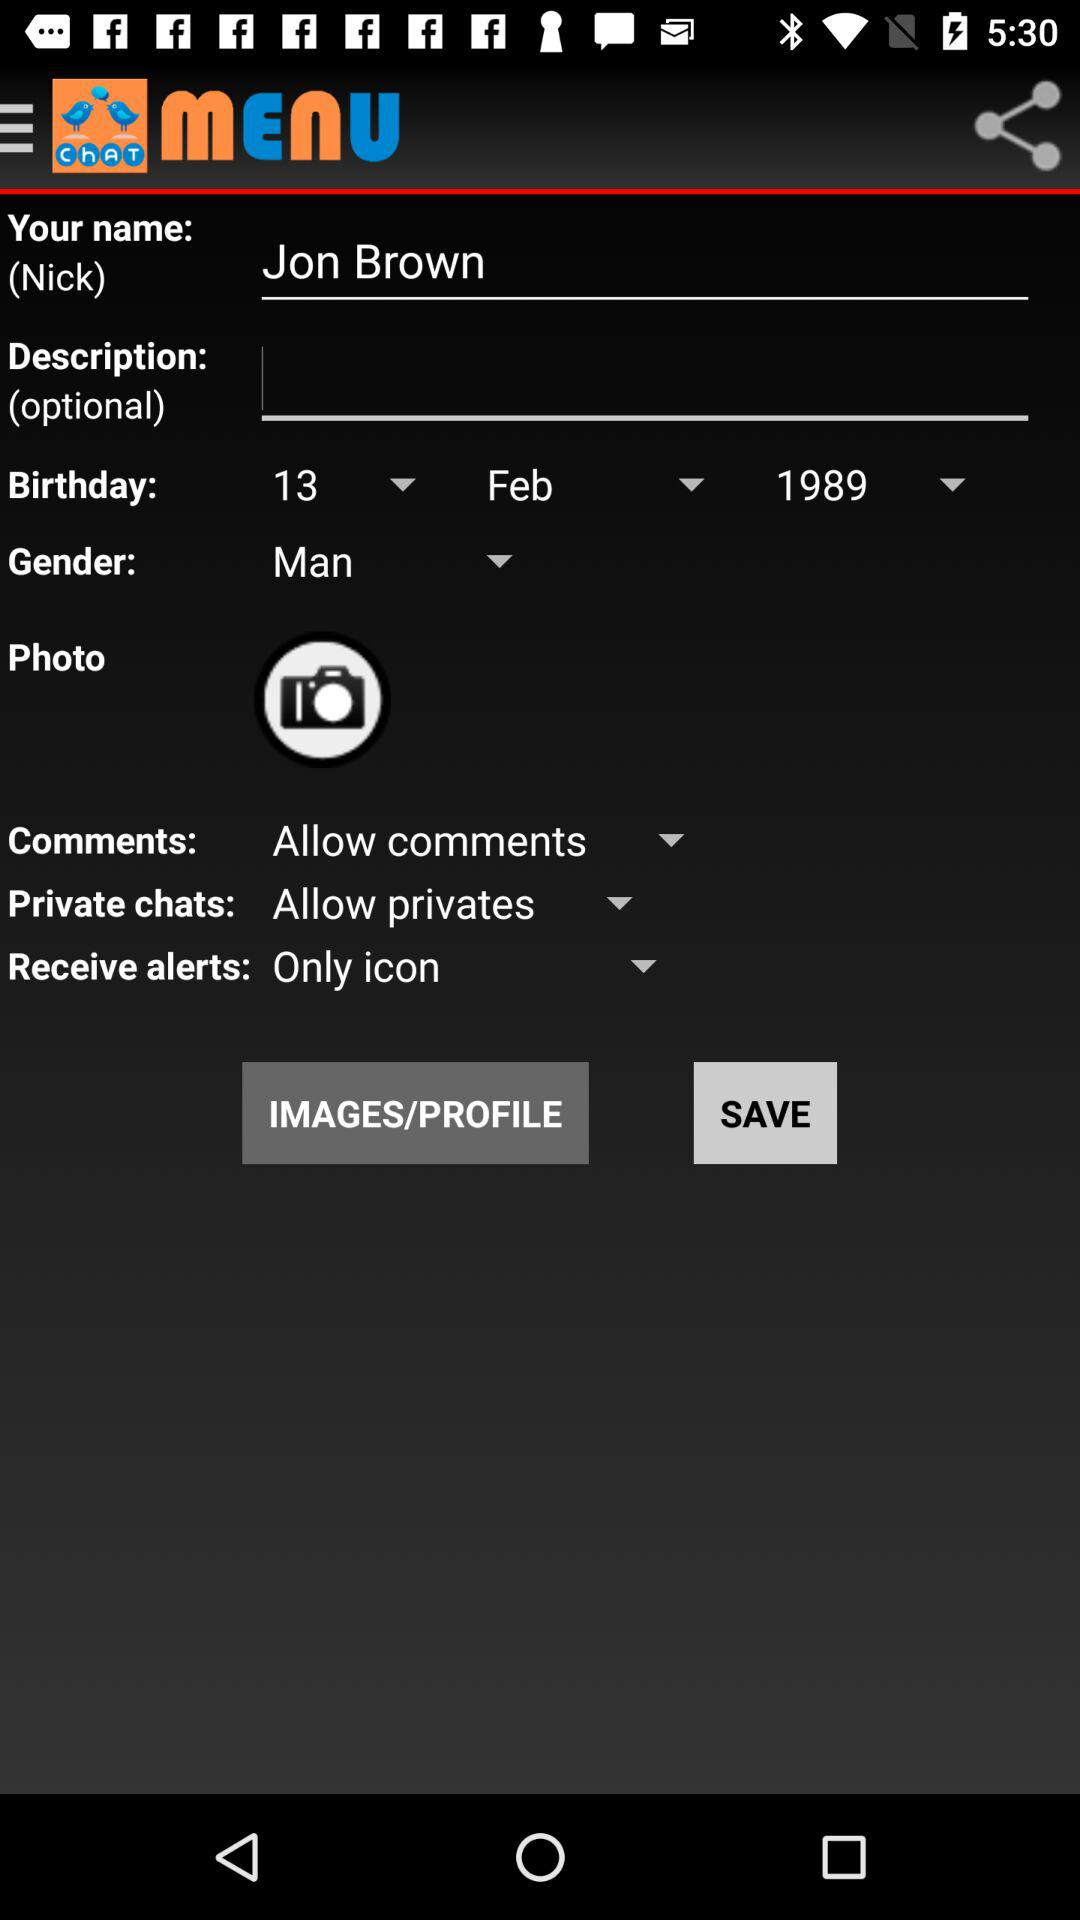What is the name? The name is Jon Brown. 